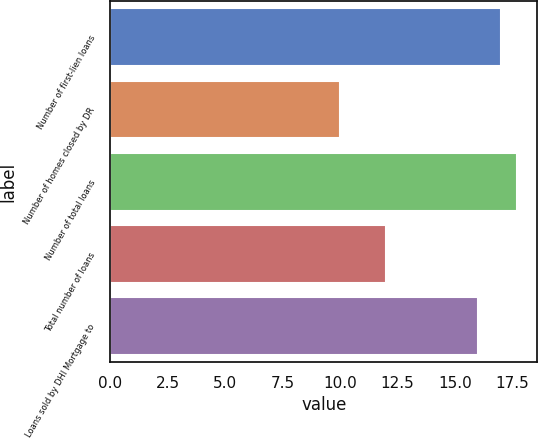<chart> <loc_0><loc_0><loc_500><loc_500><bar_chart><fcel>Number of first-lien loans<fcel>Number of homes closed by DR<fcel>Number of total loans<fcel>Total number of loans<fcel>Loans sold by DHI Mortgage to<nl><fcel>17<fcel>10<fcel>17.7<fcel>12<fcel>16<nl></chart> 